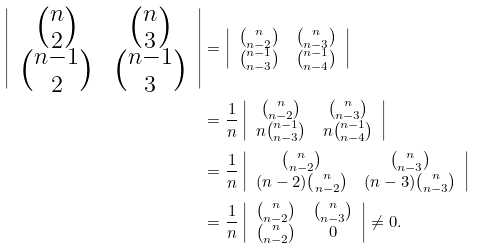<formula> <loc_0><loc_0><loc_500><loc_500>\left | \begin{array} { c c c } { n \choose 2 } & { n \choose 3 } \\ { n - 1 \choose 2 } & { n - 1 \choose 3 } \\ \end{array} \right | & = \left | \begin{array} { c c c } { n \choose n - 2 } & { n \choose n - 3 } \\ { n - 1 \choose n - 3 } & { n - 1 \choose n - 4 } \\ \end{array} \right | \\ & = \frac { 1 } { n } \left | \begin{array} { c c c } { n \choose n - 2 } & { n \choose n - 3 } \\ n { n - 1 \choose n - 3 } & n { n - 1 \choose n - 4 } \\ \end{array} \right | \\ & = \frac { 1 } { n } \left | \begin{array} { c c c } { n \choose n - 2 } & { n \choose n - 3 } \\ ( n - 2 ) { n \choose n - 2 } & ( n - 3 ) { n \choose n - 3 } \\ \end{array} \right | \\ & = \frac { 1 } { n } \left | \begin{array} { c c c } { n \choose n - 2 } & { n \choose n - 3 } \\ { n \choose n - 2 } & 0 \\ \end{array} \right | \neq 0 .</formula> 